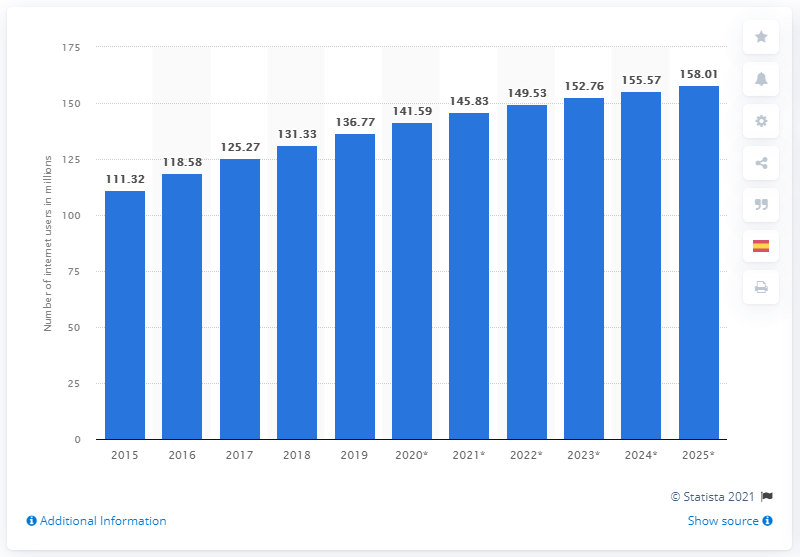Give some essential details in this illustration. In 2019, Brazil had 136.77 million internet users. By 2025, it is expected that a significant number of people will be using the internet. 